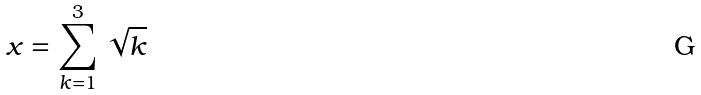Convert formula to latex. <formula><loc_0><loc_0><loc_500><loc_500>x = \sum _ { k = 1 } ^ { 3 } \sqrt { k }</formula> 